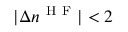<formula> <loc_0><loc_0><loc_500><loc_500>| \Delta n ^ { H F } | < 2</formula> 